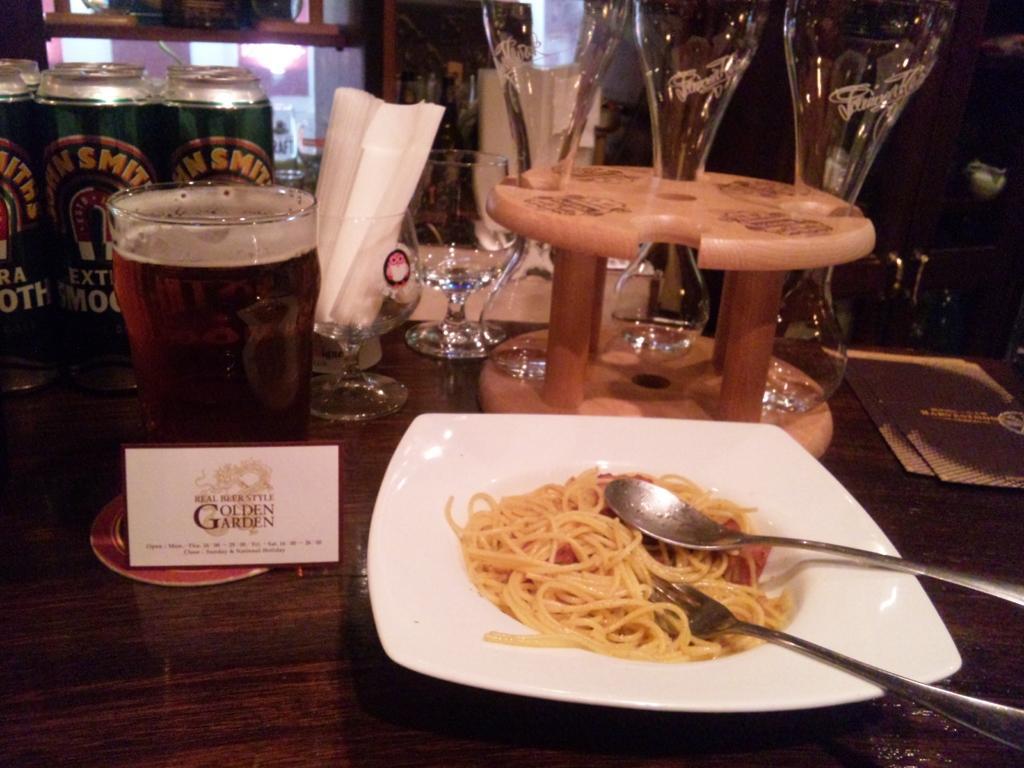How would you summarize this image in a sentence or two? This picture shows some food in the plate and we see a fork and a spoon and couple of glasses and glass with beer and few napkins and cans on the side 